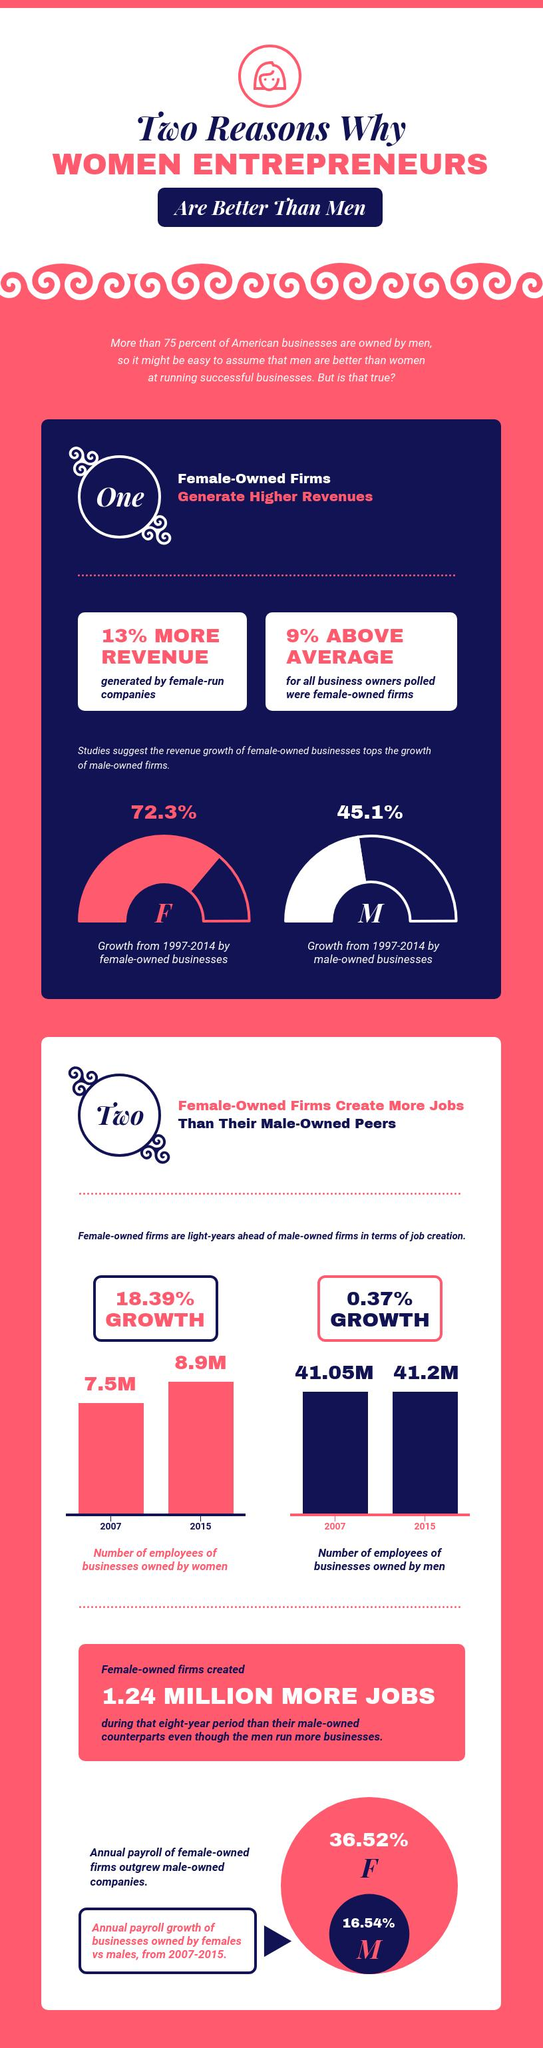Outline some significant characteristics in this image. According to the data, women-owned firms outperform male-owned firms in job creation, with a 18.02% higher rate of job creation. According to the data, the revenue of female-owned businesses is 27.2% lower than that of male-owned businesses. In terms of annual payroll as a percentage of business, females had a higher percentage than males. 